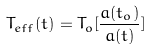<formula> <loc_0><loc_0><loc_500><loc_500>T _ { e f f } ( t ) = T _ { o } [ \frac { a ( t _ { o } ) } { a ( t ) } ]</formula> 